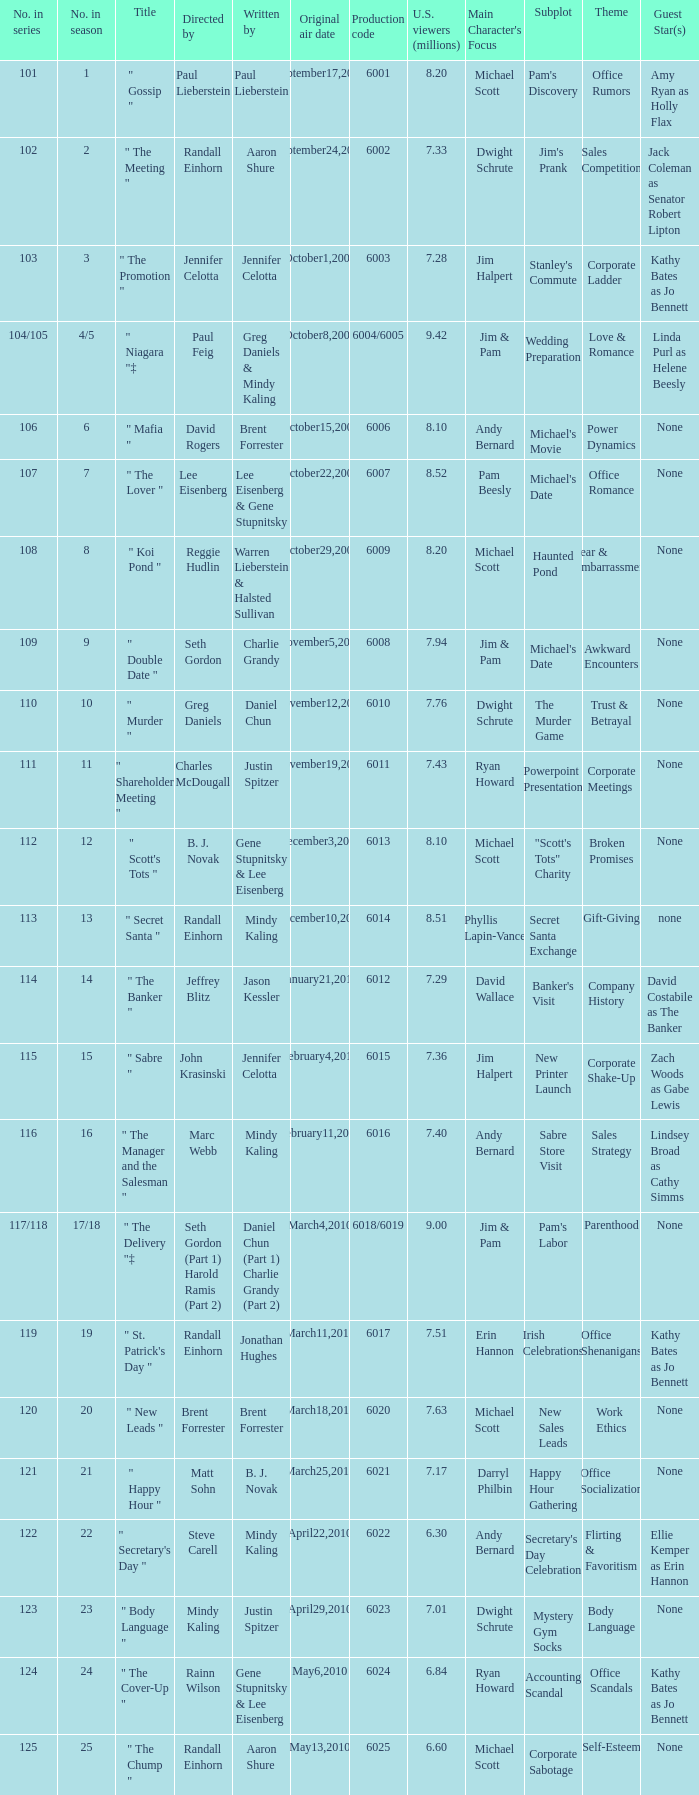Name the production code by paul lieberstein 6001.0. 